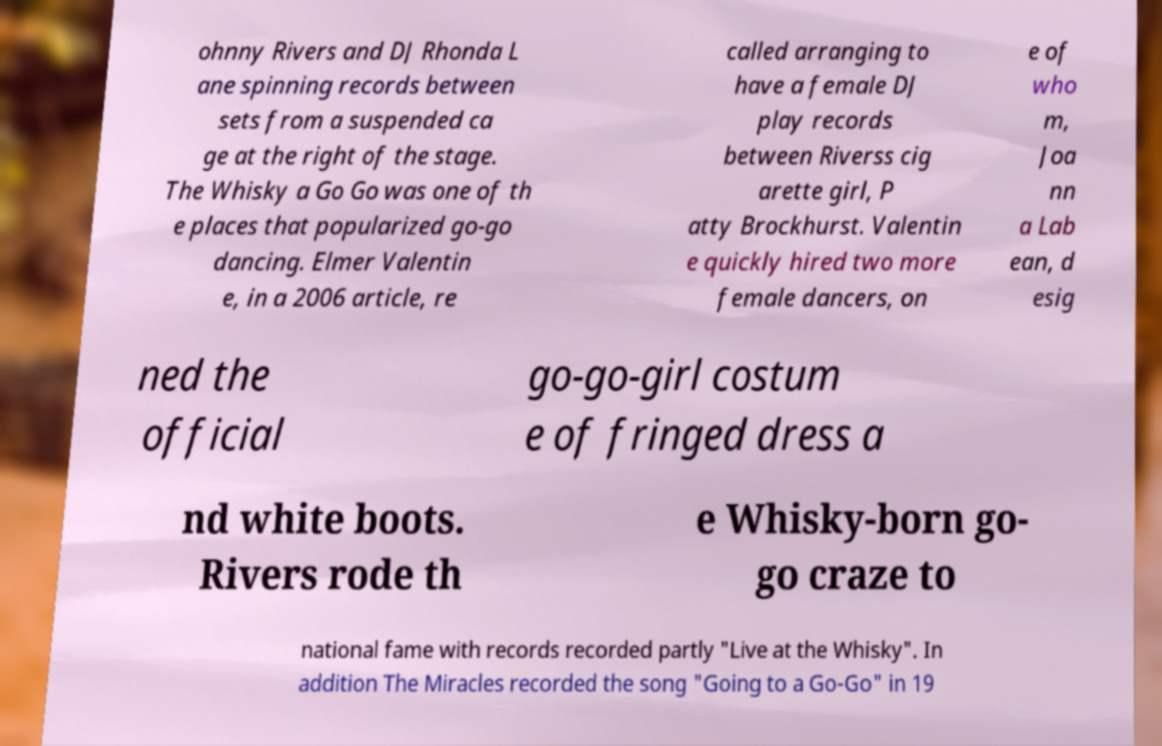Could you extract and type out the text from this image? ohnny Rivers and DJ Rhonda L ane spinning records between sets from a suspended ca ge at the right of the stage. The Whisky a Go Go was one of th e places that popularized go-go dancing. Elmer Valentin e, in a 2006 article, re called arranging to have a female DJ play records between Riverss cig arette girl, P atty Brockhurst. Valentin e quickly hired two more female dancers, on e of who m, Joa nn a Lab ean, d esig ned the official go-go-girl costum e of fringed dress a nd white boots. Rivers rode th e Whisky-born go- go craze to national fame with records recorded partly "Live at the Whisky". In addition The Miracles recorded the song "Going to a Go-Go" in 19 